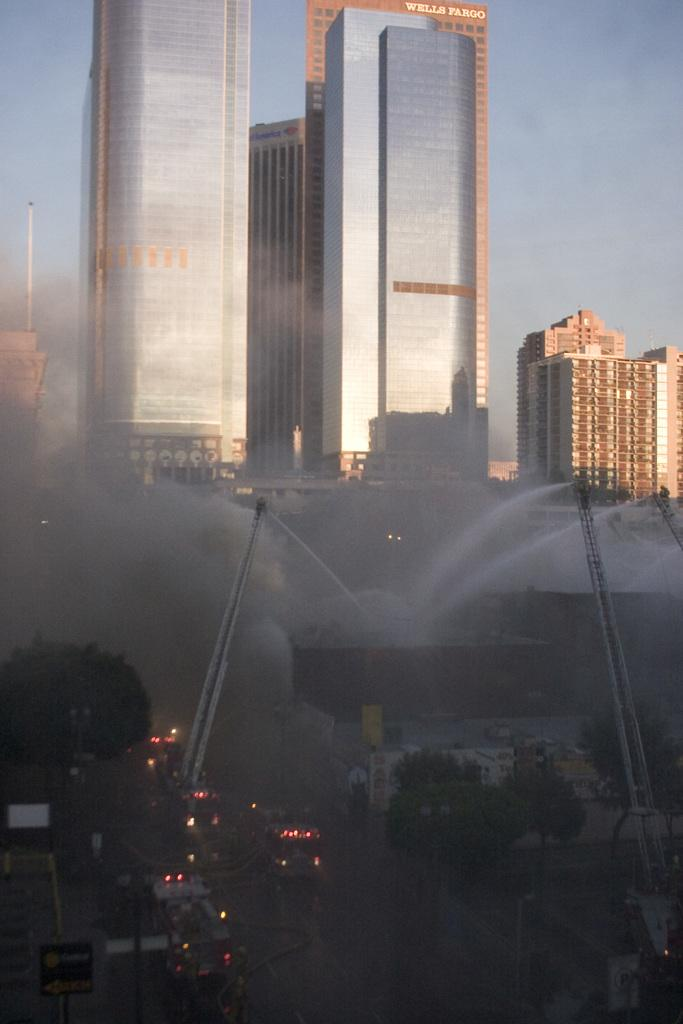What type of structures can be seen in the image? There are buildings in the image. What other elements are present in the image besides buildings? There are trees, boards, vehicles, lights, and poles in the image. What can be seen in the background of the image? The sky is visible in the background of the image. How does the feeling of the image change throughout the day? The image itself does not have feelings, as it is a static representation. The perception of the image may change depending on the viewer's emotions or the time of day, but the image itself remains unchanged. 